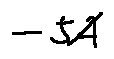<formula> <loc_0><loc_0><loc_500><loc_500>- 5 A</formula> 